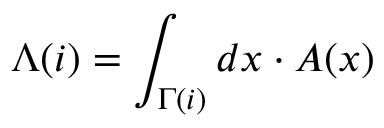<formula> <loc_0><loc_0><loc_500><loc_500>\Lambda ( i ) = \int _ { \Gamma ( i ) } d x \cdot A ( x )</formula> 